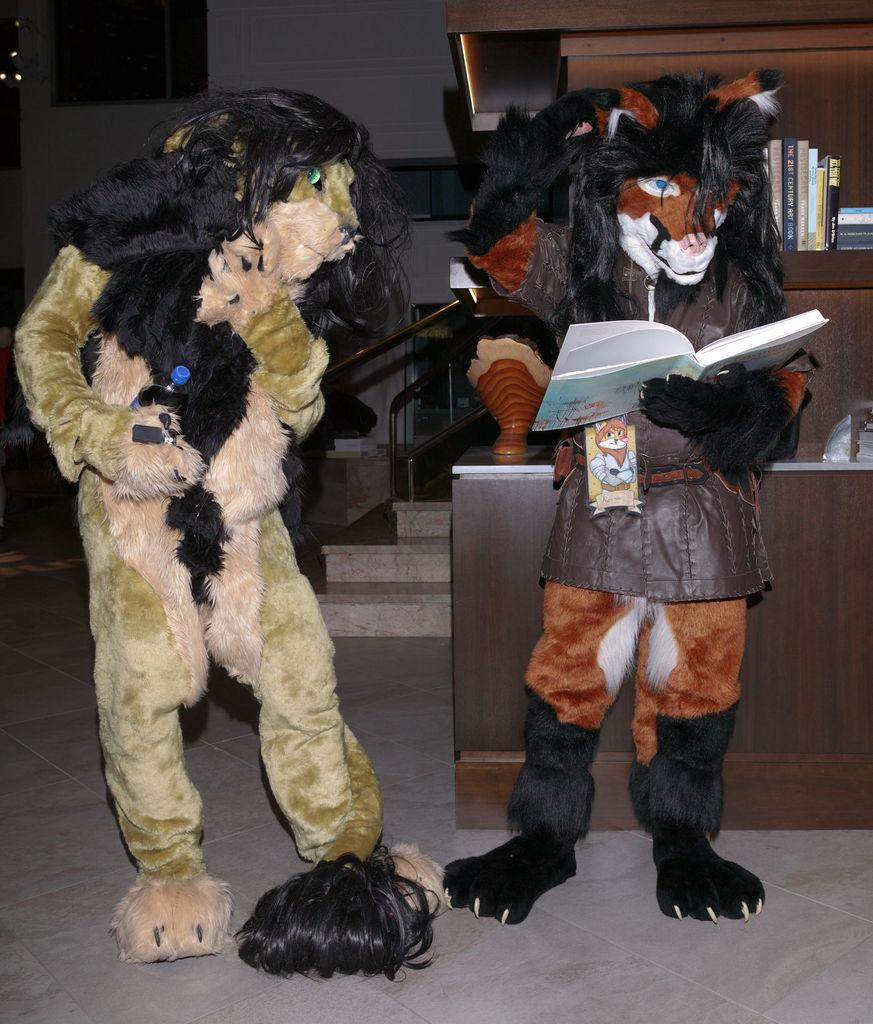What is the toy on the right side of the image holding? The toy on the right side of the image is holding a book. What is the toy on the left side of the image holding? The toy on the left side of the image is holding a bottle. What can be seen in the background of the image? In the background of the image, there are books, toys, a staircase, and a wall. Where is the father of the geese in the image? There are no geese or their father present in the image. What type of mine is visible in the image? There is no mine present in the image. 